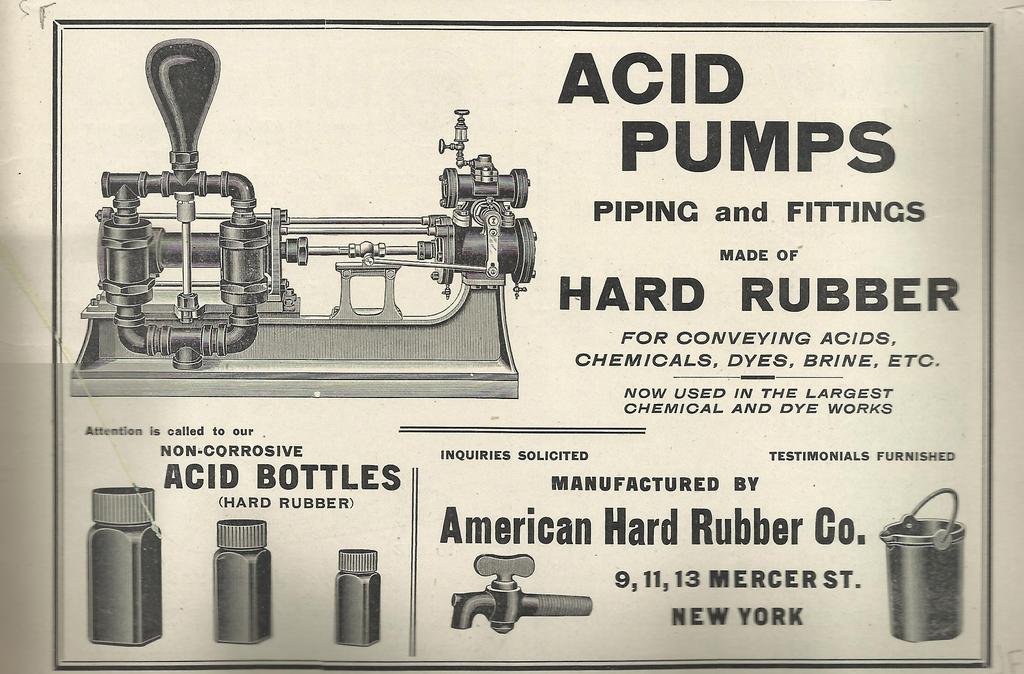What state is this made in?
Make the answer very short. New york. What product is being advertised?
Provide a short and direct response. Acid pumps. 